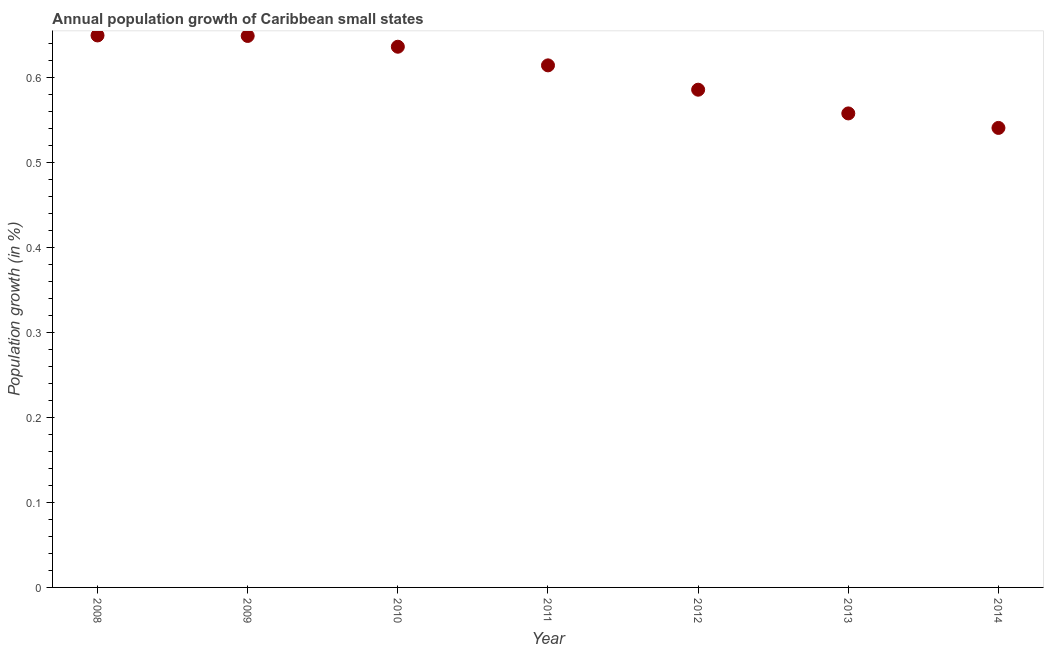What is the population growth in 2009?
Offer a terse response. 0.65. Across all years, what is the maximum population growth?
Offer a terse response. 0.65. Across all years, what is the minimum population growth?
Offer a very short reply. 0.54. In which year was the population growth minimum?
Offer a terse response. 2014. What is the sum of the population growth?
Ensure brevity in your answer.  4.24. What is the difference between the population growth in 2010 and 2014?
Give a very brief answer. 0.1. What is the average population growth per year?
Your response must be concise. 0.61. What is the median population growth?
Your answer should be very brief. 0.61. Do a majority of the years between 2013 and 2010 (inclusive) have population growth greater than 0.42000000000000004 %?
Your answer should be very brief. Yes. What is the ratio of the population growth in 2008 to that in 2014?
Ensure brevity in your answer.  1.2. What is the difference between the highest and the second highest population growth?
Your response must be concise. 0. What is the difference between the highest and the lowest population growth?
Provide a short and direct response. 0.11. In how many years, is the population growth greater than the average population growth taken over all years?
Ensure brevity in your answer.  4. Does the population growth monotonically increase over the years?
Your response must be concise. No. How many dotlines are there?
Provide a short and direct response. 1. How many years are there in the graph?
Offer a very short reply. 7. Does the graph contain grids?
Make the answer very short. No. What is the title of the graph?
Provide a succinct answer. Annual population growth of Caribbean small states. What is the label or title of the Y-axis?
Ensure brevity in your answer.  Population growth (in %). What is the Population growth (in %) in 2008?
Offer a very short reply. 0.65. What is the Population growth (in %) in 2009?
Your response must be concise. 0.65. What is the Population growth (in %) in 2010?
Provide a succinct answer. 0.64. What is the Population growth (in %) in 2011?
Keep it short and to the point. 0.61. What is the Population growth (in %) in 2012?
Offer a terse response. 0.59. What is the Population growth (in %) in 2013?
Ensure brevity in your answer.  0.56. What is the Population growth (in %) in 2014?
Provide a succinct answer. 0.54. What is the difference between the Population growth (in %) in 2008 and 2009?
Ensure brevity in your answer.  0. What is the difference between the Population growth (in %) in 2008 and 2010?
Give a very brief answer. 0.01. What is the difference between the Population growth (in %) in 2008 and 2011?
Your response must be concise. 0.04. What is the difference between the Population growth (in %) in 2008 and 2012?
Provide a succinct answer. 0.06. What is the difference between the Population growth (in %) in 2008 and 2013?
Ensure brevity in your answer.  0.09. What is the difference between the Population growth (in %) in 2008 and 2014?
Your answer should be very brief. 0.11. What is the difference between the Population growth (in %) in 2009 and 2010?
Provide a succinct answer. 0.01. What is the difference between the Population growth (in %) in 2009 and 2011?
Give a very brief answer. 0.03. What is the difference between the Population growth (in %) in 2009 and 2012?
Keep it short and to the point. 0.06. What is the difference between the Population growth (in %) in 2009 and 2013?
Make the answer very short. 0.09. What is the difference between the Population growth (in %) in 2009 and 2014?
Give a very brief answer. 0.11. What is the difference between the Population growth (in %) in 2010 and 2011?
Ensure brevity in your answer.  0.02. What is the difference between the Population growth (in %) in 2010 and 2012?
Your response must be concise. 0.05. What is the difference between the Population growth (in %) in 2010 and 2013?
Offer a very short reply. 0.08. What is the difference between the Population growth (in %) in 2010 and 2014?
Make the answer very short. 0.1. What is the difference between the Population growth (in %) in 2011 and 2012?
Your answer should be very brief. 0.03. What is the difference between the Population growth (in %) in 2011 and 2013?
Provide a succinct answer. 0.06. What is the difference between the Population growth (in %) in 2011 and 2014?
Offer a terse response. 0.07. What is the difference between the Population growth (in %) in 2012 and 2013?
Offer a terse response. 0.03. What is the difference between the Population growth (in %) in 2012 and 2014?
Provide a short and direct response. 0.04. What is the difference between the Population growth (in %) in 2013 and 2014?
Give a very brief answer. 0.02. What is the ratio of the Population growth (in %) in 2008 to that in 2010?
Offer a terse response. 1.02. What is the ratio of the Population growth (in %) in 2008 to that in 2011?
Give a very brief answer. 1.06. What is the ratio of the Population growth (in %) in 2008 to that in 2012?
Ensure brevity in your answer.  1.11. What is the ratio of the Population growth (in %) in 2008 to that in 2013?
Your answer should be compact. 1.16. What is the ratio of the Population growth (in %) in 2008 to that in 2014?
Your answer should be compact. 1.2. What is the ratio of the Population growth (in %) in 2009 to that in 2011?
Your answer should be compact. 1.06. What is the ratio of the Population growth (in %) in 2009 to that in 2012?
Provide a short and direct response. 1.11. What is the ratio of the Population growth (in %) in 2009 to that in 2013?
Your response must be concise. 1.16. What is the ratio of the Population growth (in %) in 2009 to that in 2014?
Your response must be concise. 1.2. What is the ratio of the Population growth (in %) in 2010 to that in 2011?
Offer a terse response. 1.04. What is the ratio of the Population growth (in %) in 2010 to that in 2012?
Keep it short and to the point. 1.09. What is the ratio of the Population growth (in %) in 2010 to that in 2013?
Your answer should be compact. 1.14. What is the ratio of the Population growth (in %) in 2010 to that in 2014?
Give a very brief answer. 1.18. What is the ratio of the Population growth (in %) in 2011 to that in 2012?
Make the answer very short. 1.05. What is the ratio of the Population growth (in %) in 2011 to that in 2013?
Make the answer very short. 1.1. What is the ratio of the Population growth (in %) in 2011 to that in 2014?
Make the answer very short. 1.14. What is the ratio of the Population growth (in %) in 2012 to that in 2014?
Provide a short and direct response. 1.08. What is the ratio of the Population growth (in %) in 2013 to that in 2014?
Offer a very short reply. 1.03. 